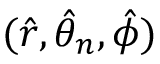Convert formula to latex. <formula><loc_0><loc_0><loc_500><loc_500>( \hat { r } , \hat { \theta } _ { n } , \hat { \phi } )</formula> 